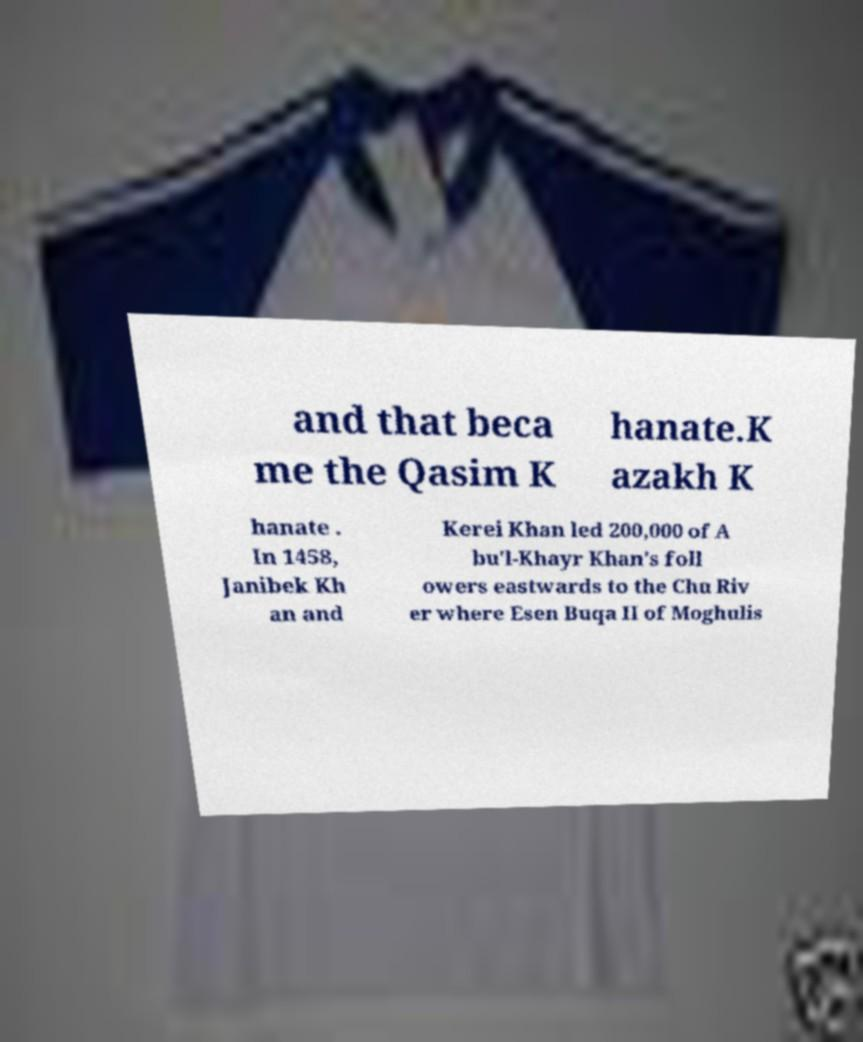Can you read and provide the text displayed in the image?This photo seems to have some interesting text. Can you extract and type it out for me? and that beca me the Qasim K hanate.K azakh K hanate . In 1458, Janibek Kh an and Kerei Khan led 200,000 of A bu'l-Khayr Khan's foll owers eastwards to the Chu Riv er where Esen Buqa II of Moghulis 